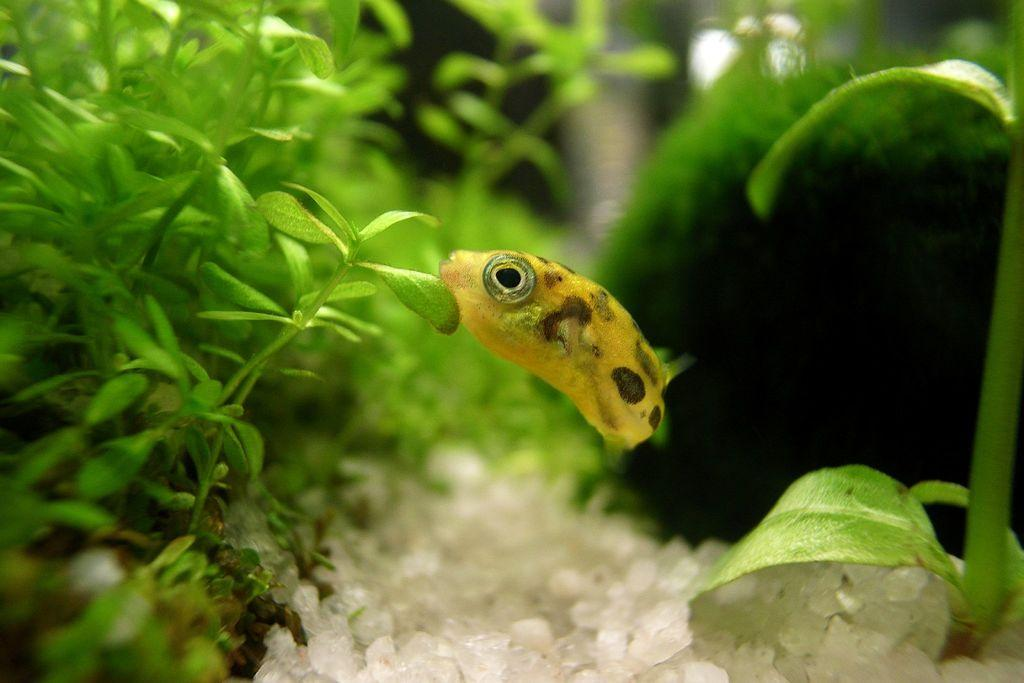What type of animal is present in the image? There is a fish in the image. What other elements can be seen in the image besides the fish? There are plants in the image. What type of tool does the fish use to build furniture in the image? There is no tool or furniture present in the image; it only features a fish and plants. 